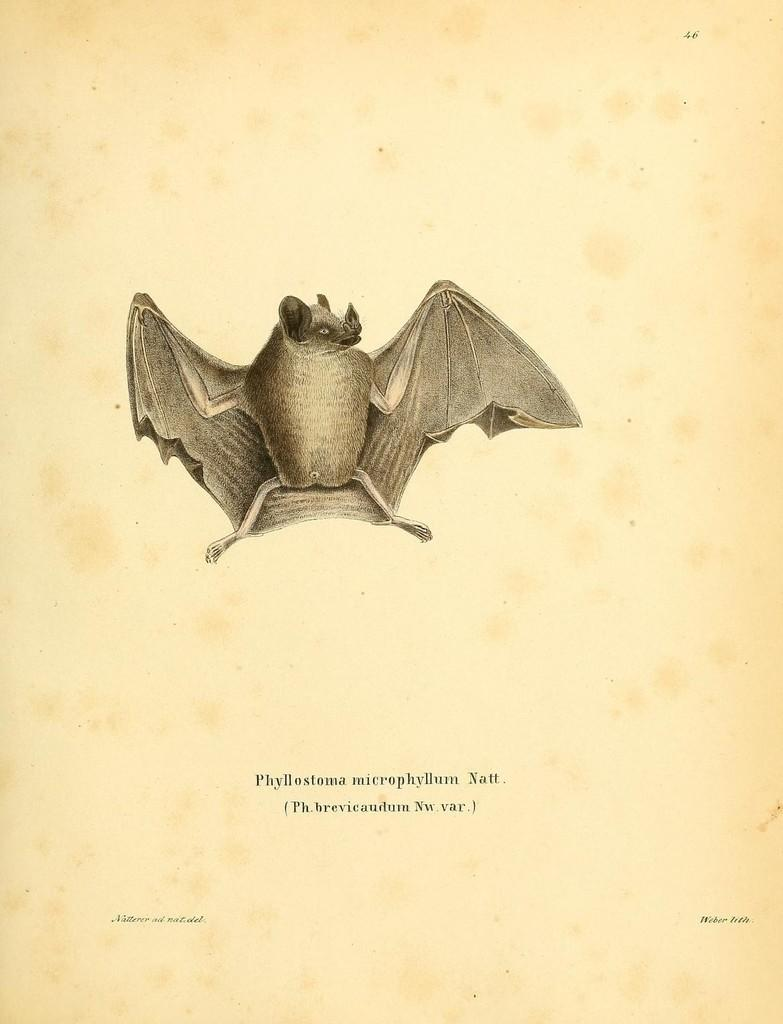What is the main subject of the image? There is a painting in the image. What is depicted in the painting? There is a bat in the painting. Is there any text associated with the painting? Yes, there is text written at the bottom of the painting. What type of blood is visible on the goat in the image? There is no goat or blood present in the image; it features a painting with a bat and text at the bottom. 